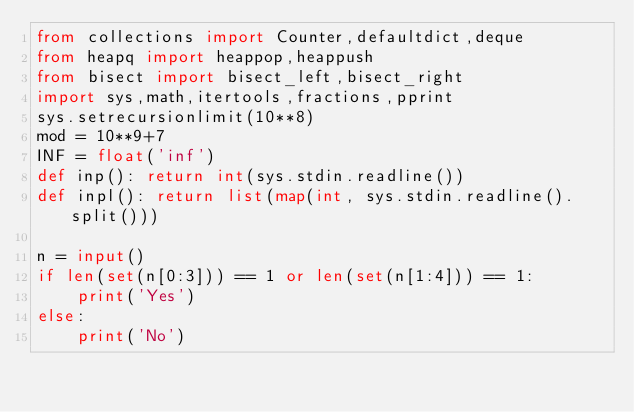<code> <loc_0><loc_0><loc_500><loc_500><_Python_>from collections import Counter,defaultdict,deque
from heapq import heappop,heappush
from bisect import bisect_left,bisect_right 
import sys,math,itertools,fractions,pprint
sys.setrecursionlimit(10**8)
mod = 10**9+7
INF = float('inf')
def inp(): return int(sys.stdin.readline())
def inpl(): return list(map(int, sys.stdin.readline().split()))

n = input()
if len(set(n[0:3])) == 1 or len(set(n[1:4])) == 1:
    print('Yes')
else:
    print('No')
</code> 